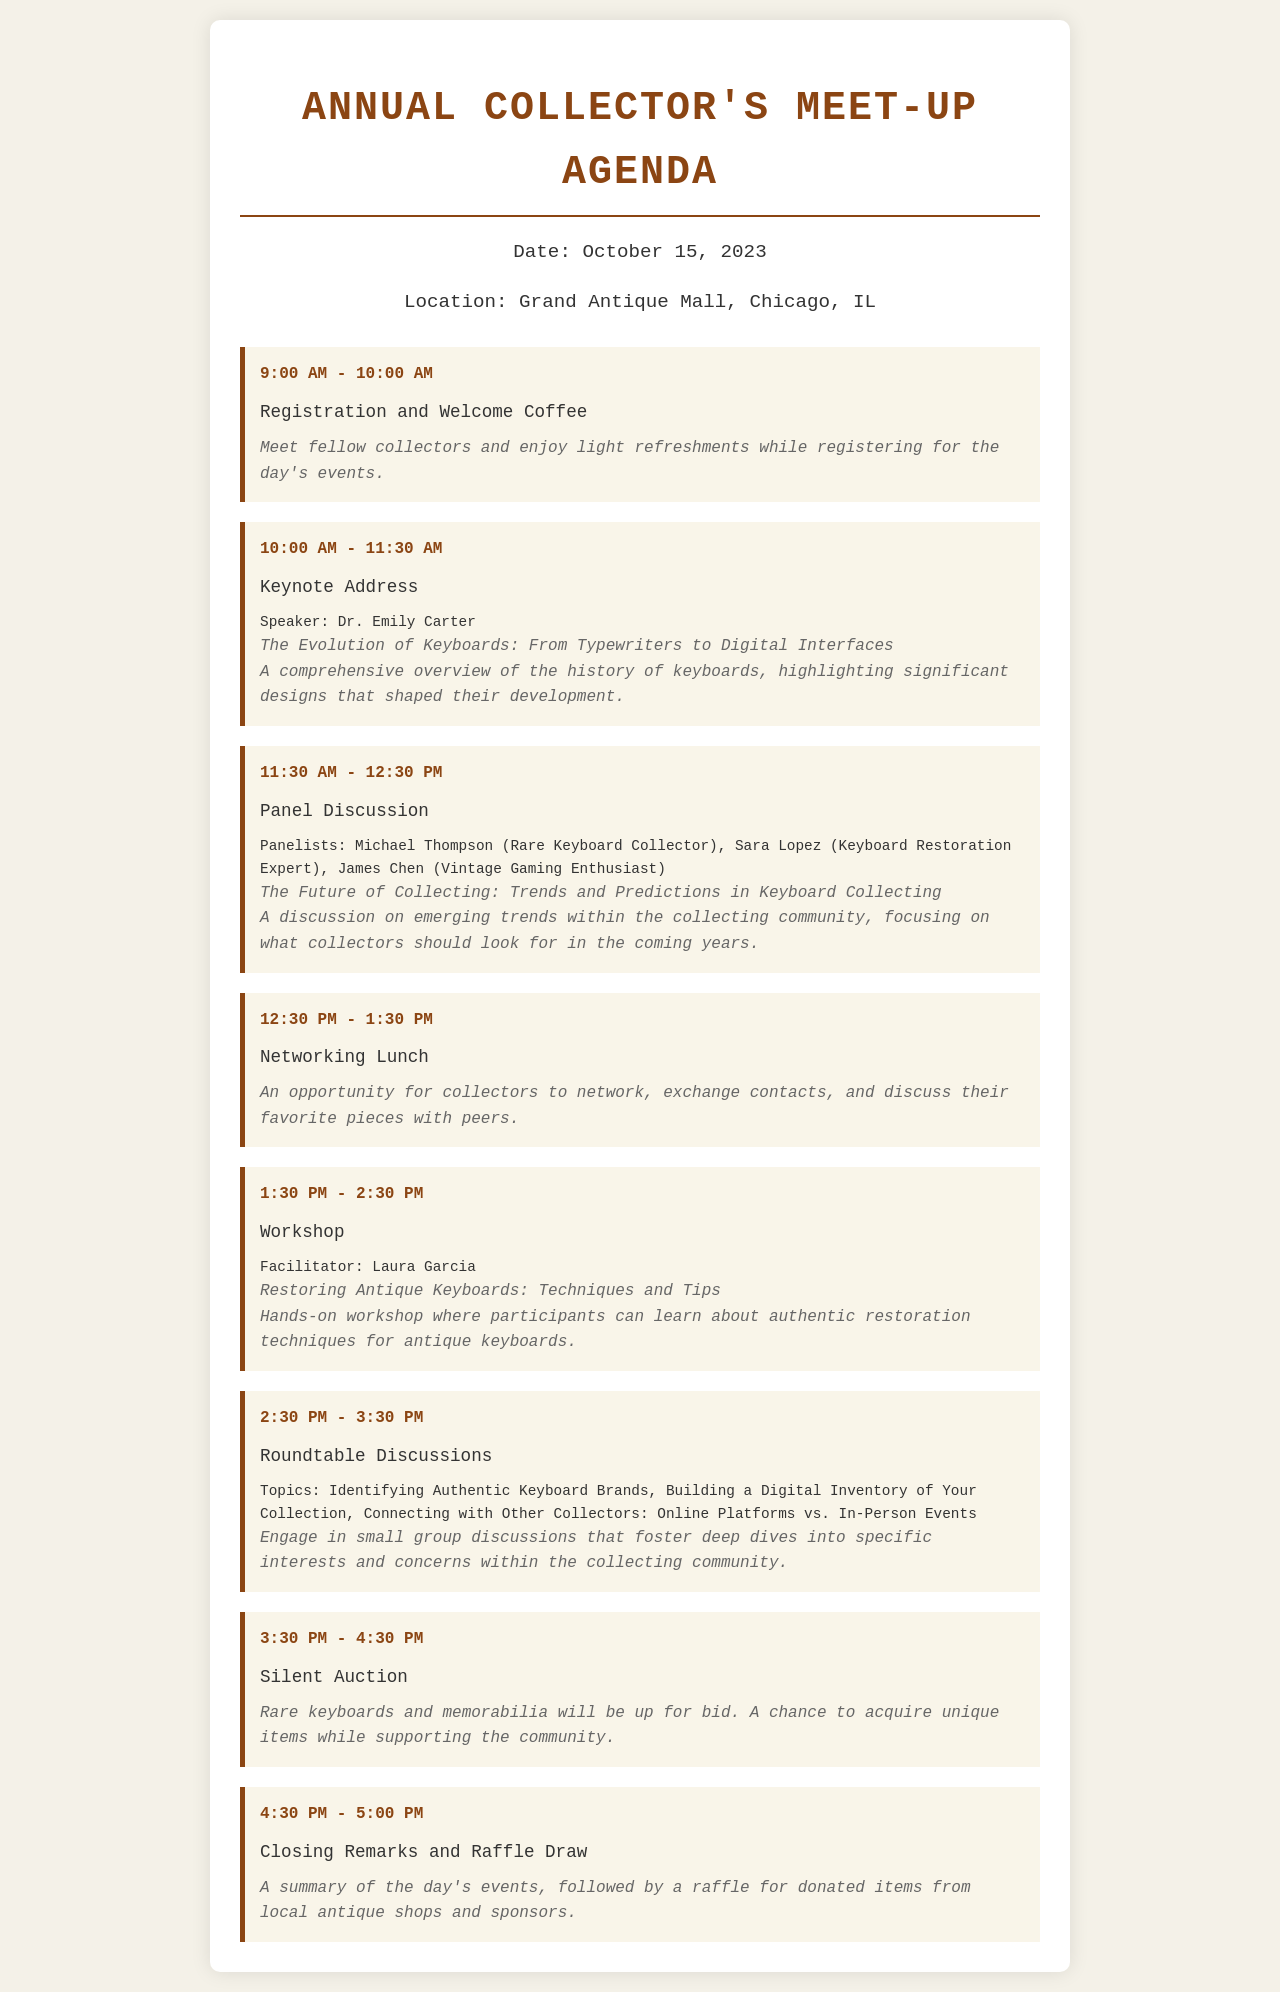What is the date of the event? The date of the event is specified in the document as October 15, 2023.
Answer: October 15, 2023 Who is the keynote speaker? The document lists Dr. Emily Carter as the keynote speaker for the address.
Answer: Dr. Emily Carter What is the topic of the keynote address? The topic of the keynote address is outlined in the document as "The Evolution of Keyboards: From Typewriters to Digital Interfaces."
Answer: The Evolution of Keyboards: From Typewriters to Digital Interfaces What time does the Networking Lunch take place? The schedule states that the Networking Lunch occurs from 12:30 PM to 1:30 PM.
Answer: 12:30 PM - 1:30 PM How many panelists are involved in the Panel Discussion? The document lists three panelists for the discussion on the future of collecting.
Answer: Three Which workshop is facilitated by Laura Garcia? The document indicates the workshop is titled "Restoring Antique Keyboards: Techniques and Tips."
Answer: Restoring Antique Keyboards: Techniques and Tips What is one of the topics covered in the Roundtable Discussions? The document mentions "Identifying Authentic Keyboard Brands" as one of the discussion topics.
Answer: Identifying Authentic Keyboard Brands What event concludes the meet-up? According to the schedule, the event concludes with "Closing Remarks and Raffle Draw."
Answer: Closing Remarks and Raffle Draw 